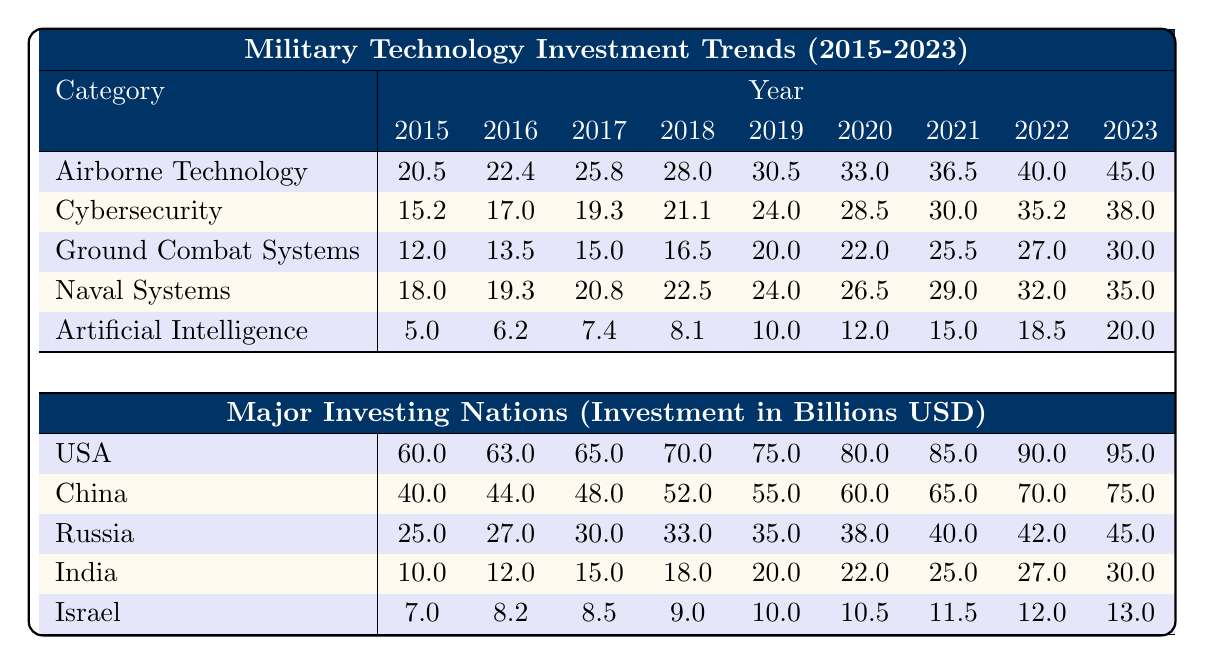What was the investment in Airborne Technology in 2023? The table shows that the investment in Airborne Technology for the year 2023 is 45.0 billion USD.
Answer: 45.0 billion USD Which category had the highest investment in 2021? In 2021, Airborne Technology had an investment of 36.5 billion USD, which is higher compared to other categories such as Cybersecurity (30.0 billion USD), Ground Combat Systems (25.5 billion USD), Naval Systems (29.0 billion USD), and Artificial Intelligence (15.0 billion USD).
Answer: Airborne Technology What is the total investment in Cybersecurity from 2015 to 2022? The total investment from 2015 to 2022 can be calculated by adding the values: 15.2 + 17.0 + 19.3 + 21.1 + 24.0 + 28.5 + 30.0 + 35.2 =  190.3 billion USD.
Answer: 190.3 billion USD Did Russia's investment in military technology increase every year from 2015 to 2023? Looking at the data, Russia's investments were: 25.0, 27.0, 30.0, 33.0, 35.0, 38.0, 40.0, 42.0, 45.0 billion USD. Each year shows an increase, confirming that the investment did indeed rise every year.
Answer: Yes What was the percentage increase in investment for Artificial Intelligence from 2015 to 2023? The investment in Artificial Intelligence increased from 5.0 billion USD in 2015 to 20.0 billion USD in 2023. The formula for percentage increase is: ((20.0 - 5.0) / 5.0) * 100 = 300%. Thus, the percentage increase is 300%.
Answer: 300% What is the average military technology investment from the USA over the years 2015 to 2023? The total investment for the USA over these years is 60.0 + 63.0 + 65.0 + 70.0 + 75.0 + 80.0 + 85.0 + 90.0 + 95.0 = 683.0 billion USD. The average is then calculated by dividing the total by 9 (the number of years), resulting in: 683.0 / 9 ≈ 75.89.
Answer: 75.89 billion USD Which country showed the lowest military technology investment in 2018? The investments for each country in 2018 were: USA (70.0), China (52.0), Russia (33.0), India (18.0), and Israel (9.0). India had the lowest investment at 18.0 billion USD.
Answer: India What was the growth rate of Naval Systems investment from 2015 to 2023? The investment in Naval Systems grew from 18.0 billion USD in 2015 to 35.0 billion USD in 2023. The growth rate is calculated as: ((35.0 - 18.0) / 18.0) * 100 = 94.44%. Thus, the growth rate is approximately 94.44%.
Answer: 94.44% 